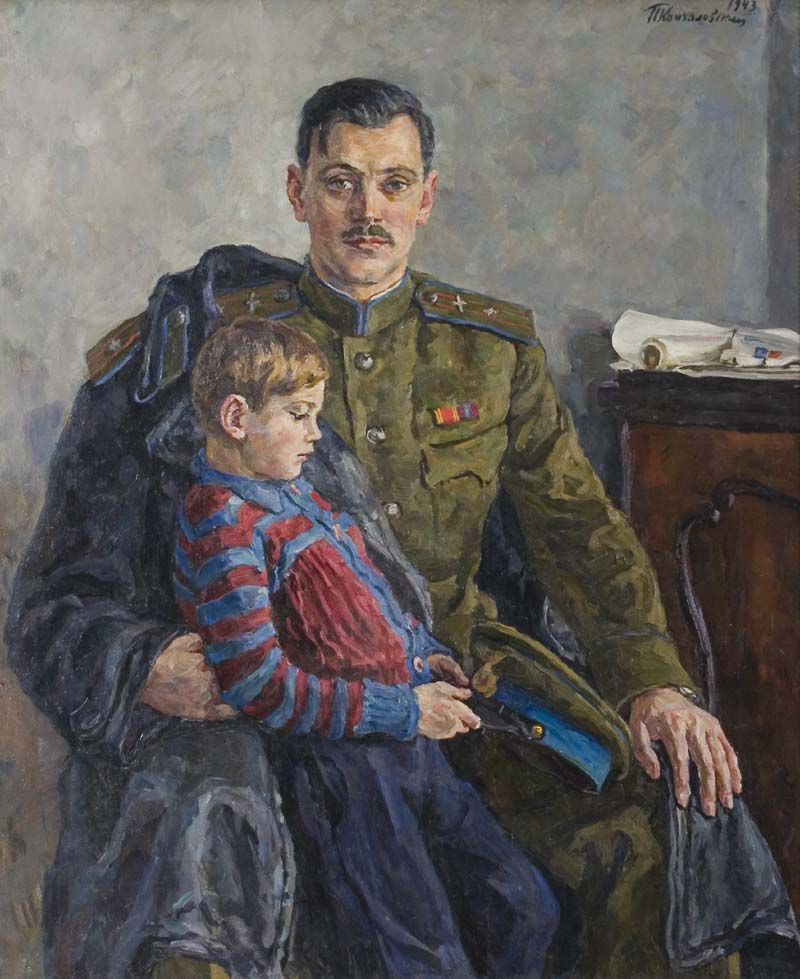Imagine the boy in the painting grows up to read his father's diary. What thoughts might he have on a page that talks about this moment captured in the painting? As the boy, now a grown man, reads his father's diary, he might come across a page describing this very moment. With mixed emotions, he could reflect on the love and pride his father felt, as evidenced by the detailed portrayal of a quiet bond amidst the rigidity of military life. Reading his father's contemplations about his duties, sacrifices, and the hopes he had for his son, the grown boy might feel a deep gratitude, understanding the weight his father carried. This page in the diary would likely be a poignant reminder of their shared moment of love, offering solace and a sense of continuity across generations. 